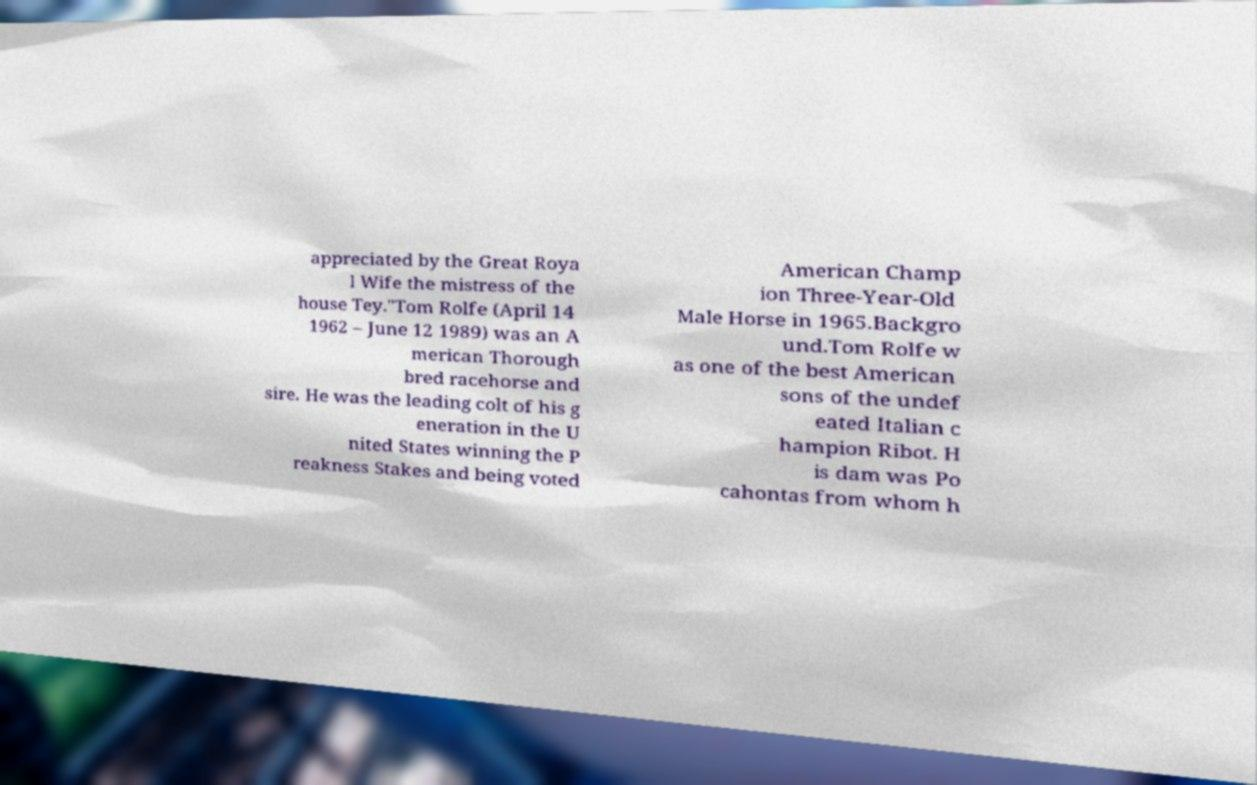Please identify and transcribe the text found in this image. appreciated by the Great Roya l Wife the mistress of the house Tey."Tom Rolfe (April 14 1962 – June 12 1989) was an A merican Thorough bred racehorse and sire. He was the leading colt of his g eneration in the U nited States winning the P reakness Stakes and being voted American Champ ion Three-Year-Old Male Horse in 1965.Backgro und.Tom Rolfe w as one of the best American sons of the undef eated Italian c hampion Ribot. H is dam was Po cahontas from whom h 